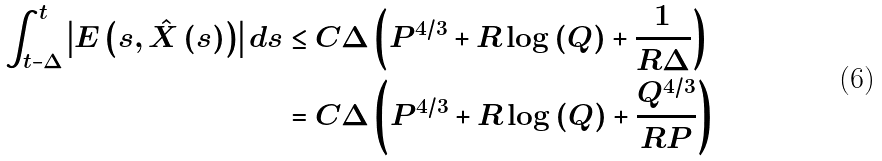Convert formula to latex. <formula><loc_0><loc_0><loc_500><loc_500>\int _ { t - \Delta } ^ { t } \left | E \left ( s , \hat { X } \left ( s \right ) \right ) \right | d s & \leq C \Delta \left ( P ^ { 4 / 3 } + R \log \left ( Q \right ) + \frac { 1 } { R \Delta } \right ) \\ & = C \Delta \left ( P ^ { 4 / 3 } + R \log \left ( Q \right ) + \frac { Q ^ { 4 / 3 } } { R P } \right )</formula> 